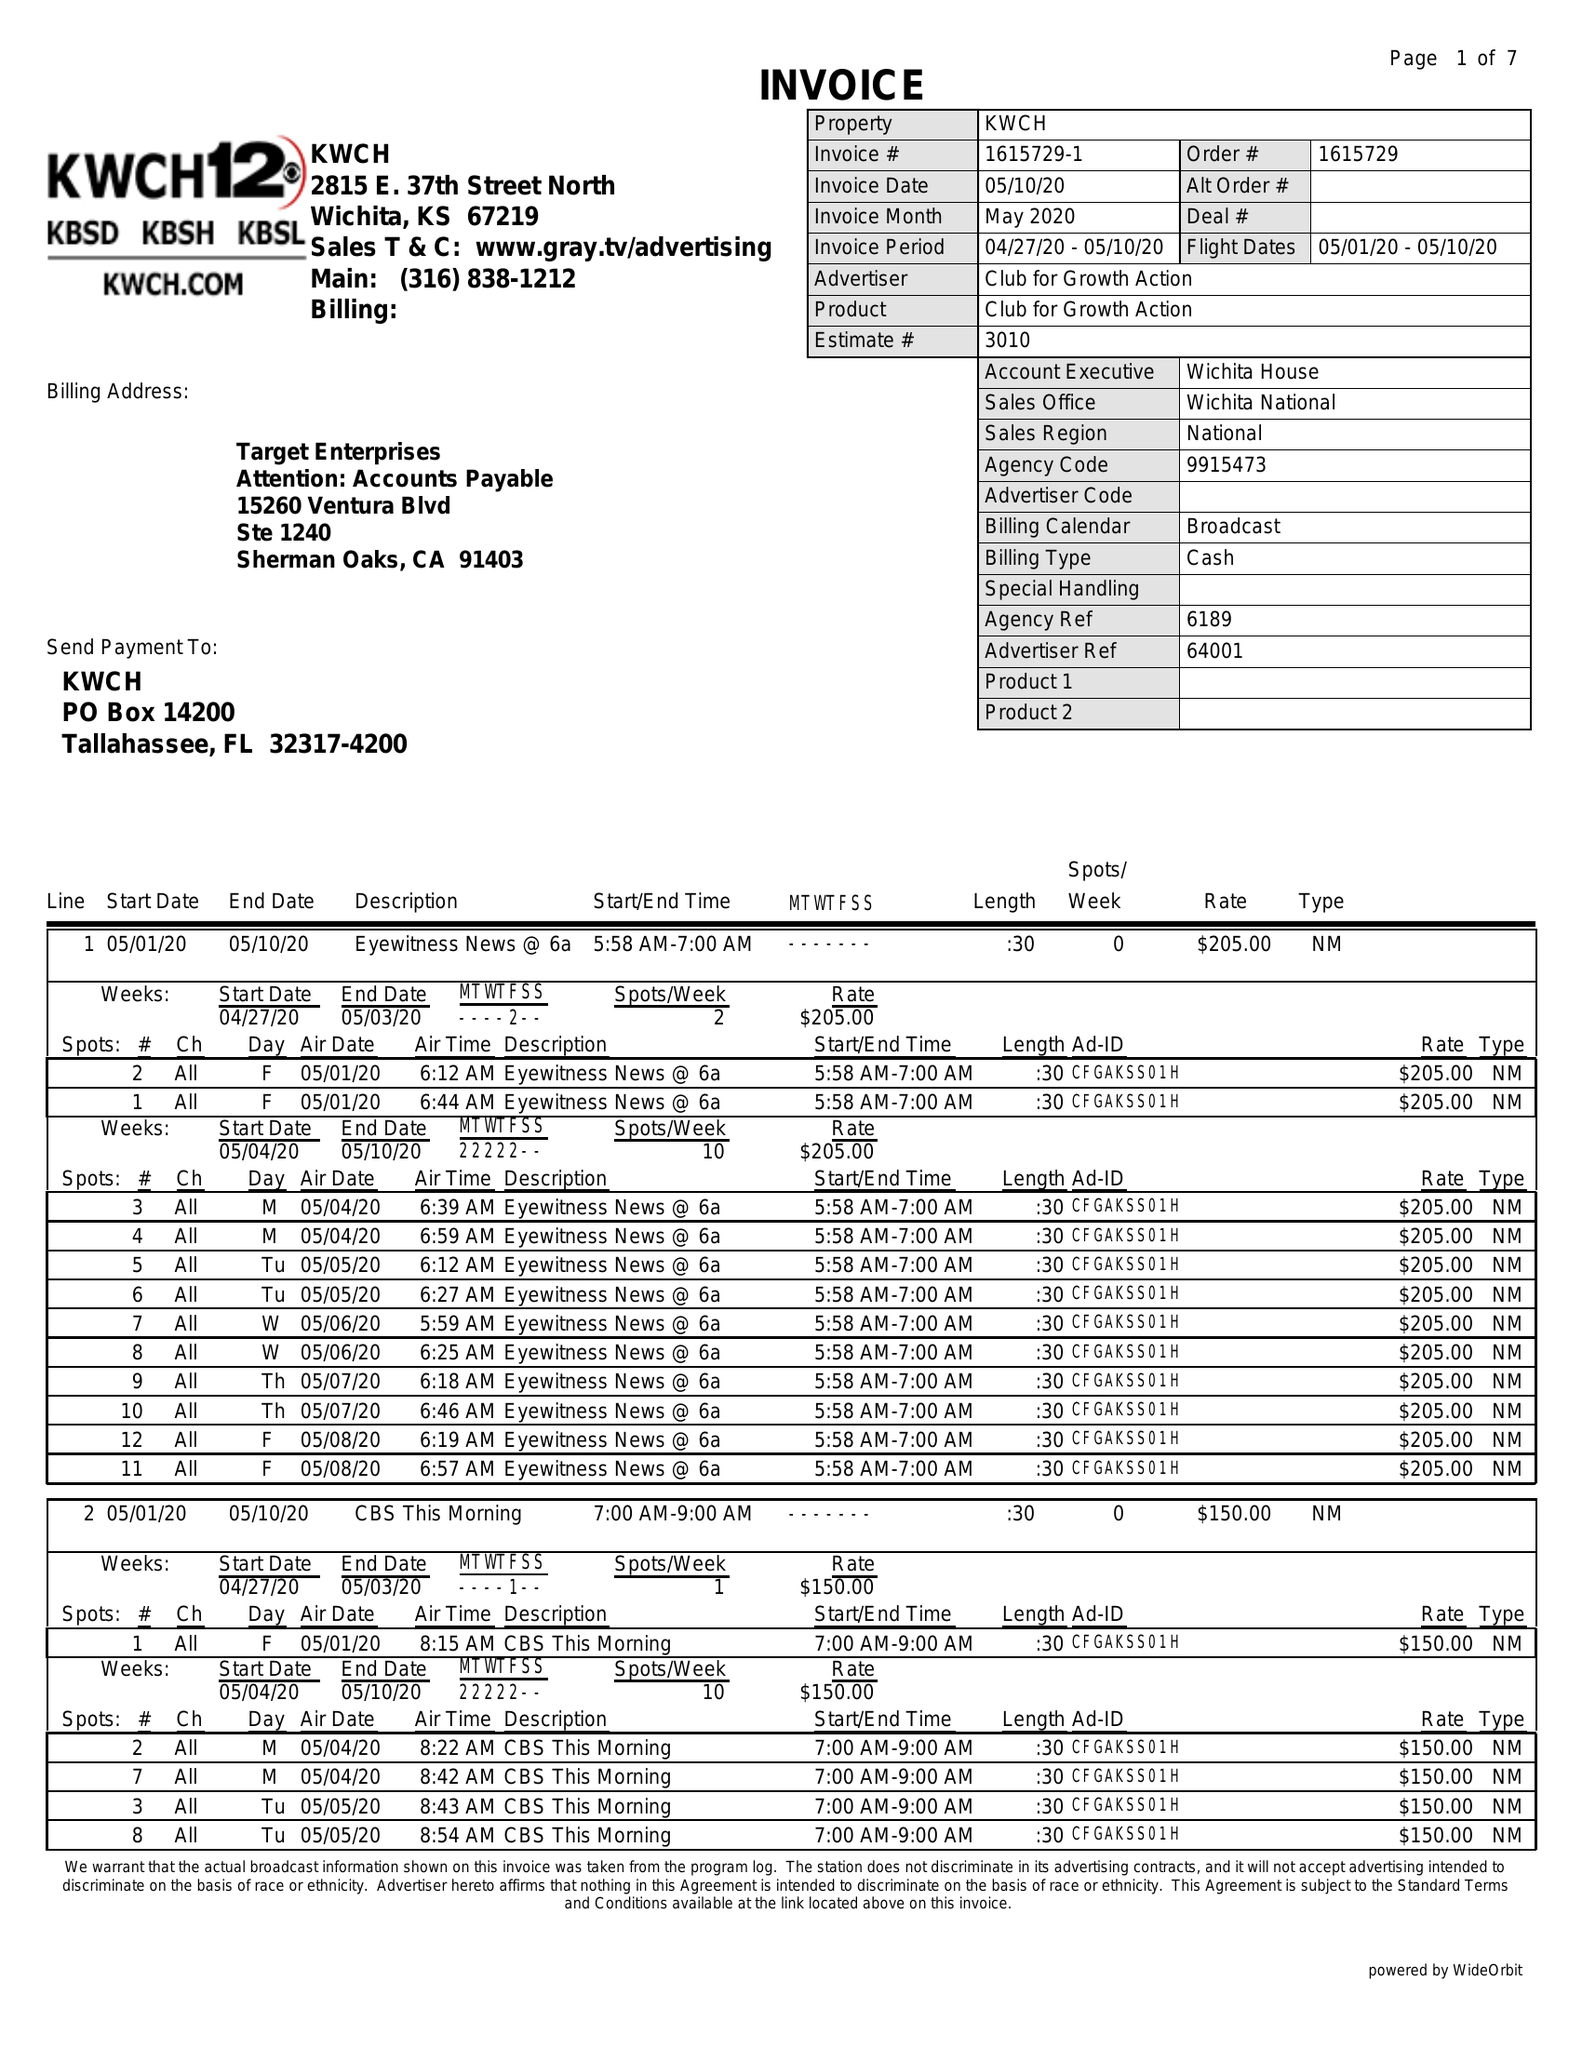What is the value for the advertiser?
Answer the question using a single word or phrase. CLUB FOR GROWTH ACTION 